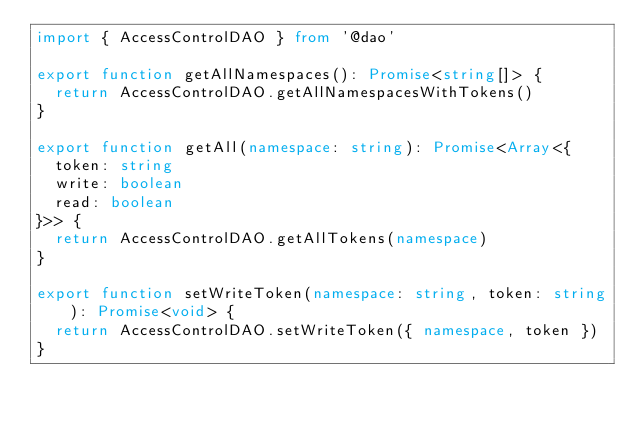<code> <loc_0><loc_0><loc_500><loc_500><_TypeScript_>import { AccessControlDAO } from '@dao'

export function getAllNamespaces(): Promise<string[]> {
  return AccessControlDAO.getAllNamespacesWithTokens()
}

export function getAll(namespace: string): Promise<Array<{
  token: string
  write: boolean
  read: boolean
}>> {
  return AccessControlDAO.getAllTokens(namespace)
}

export function setWriteToken(namespace: string, token: string): Promise<void> {
  return AccessControlDAO.setWriteToken({ namespace, token })
}
</code> 